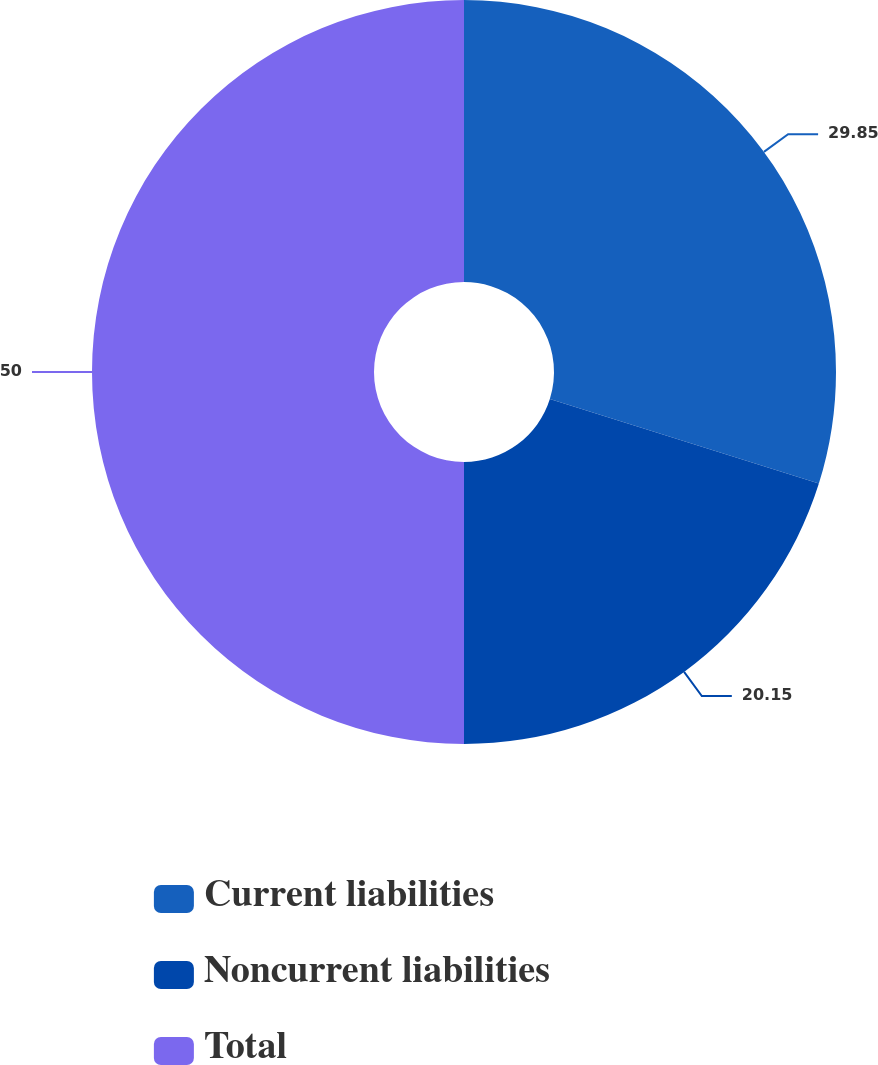Convert chart. <chart><loc_0><loc_0><loc_500><loc_500><pie_chart><fcel>Current liabilities<fcel>Noncurrent liabilities<fcel>Total<nl><fcel>29.85%<fcel>20.15%<fcel>50.0%<nl></chart> 